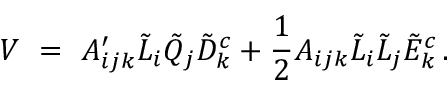<formula> <loc_0><loc_0><loc_500><loc_500>V \ = \ A _ { i j k } ^ { \prime } \tilde { L } _ { i } \tilde { Q } _ { j } \tilde { D } _ { k } ^ { c } + \frac { 1 } { 2 } A _ { i j k } \tilde { L } _ { i } \tilde { L } _ { j } \tilde { E } _ { k } ^ { c } \, .</formula> 